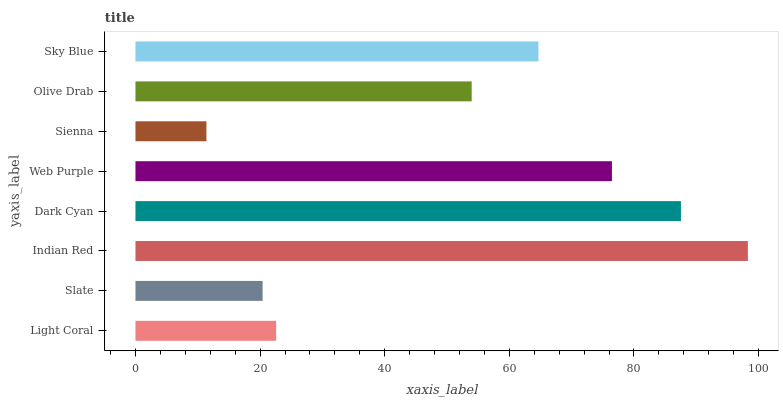Is Sienna the minimum?
Answer yes or no. Yes. Is Indian Red the maximum?
Answer yes or no. Yes. Is Slate the minimum?
Answer yes or no. No. Is Slate the maximum?
Answer yes or no. No. Is Light Coral greater than Slate?
Answer yes or no. Yes. Is Slate less than Light Coral?
Answer yes or no. Yes. Is Slate greater than Light Coral?
Answer yes or no. No. Is Light Coral less than Slate?
Answer yes or no. No. Is Sky Blue the high median?
Answer yes or no. Yes. Is Olive Drab the low median?
Answer yes or no. Yes. Is Sienna the high median?
Answer yes or no. No. Is Slate the low median?
Answer yes or no. No. 